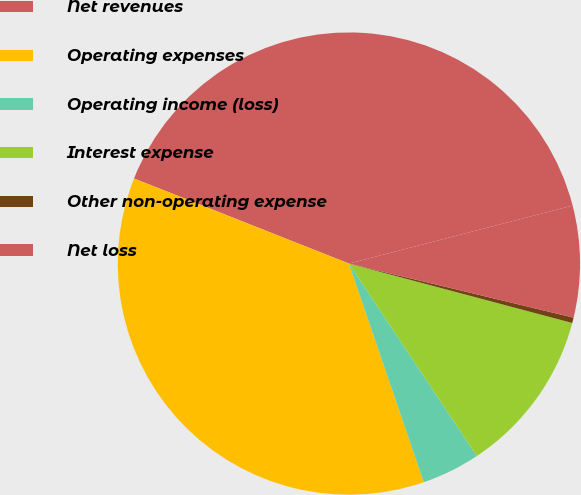<chart> <loc_0><loc_0><loc_500><loc_500><pie_chart><fcel>Net revenues<fcel>Operating expenses<fcel>Operating income (loss)<fcel>Interest expense<fcel>Other non-operating expense<fcel>Net loss<nl><fcel>39.96%<fcel>36.25%<fcel>4.09%<fcel>11.52%<fcel>0.38%<fcel>7.8%<nl></chart> 